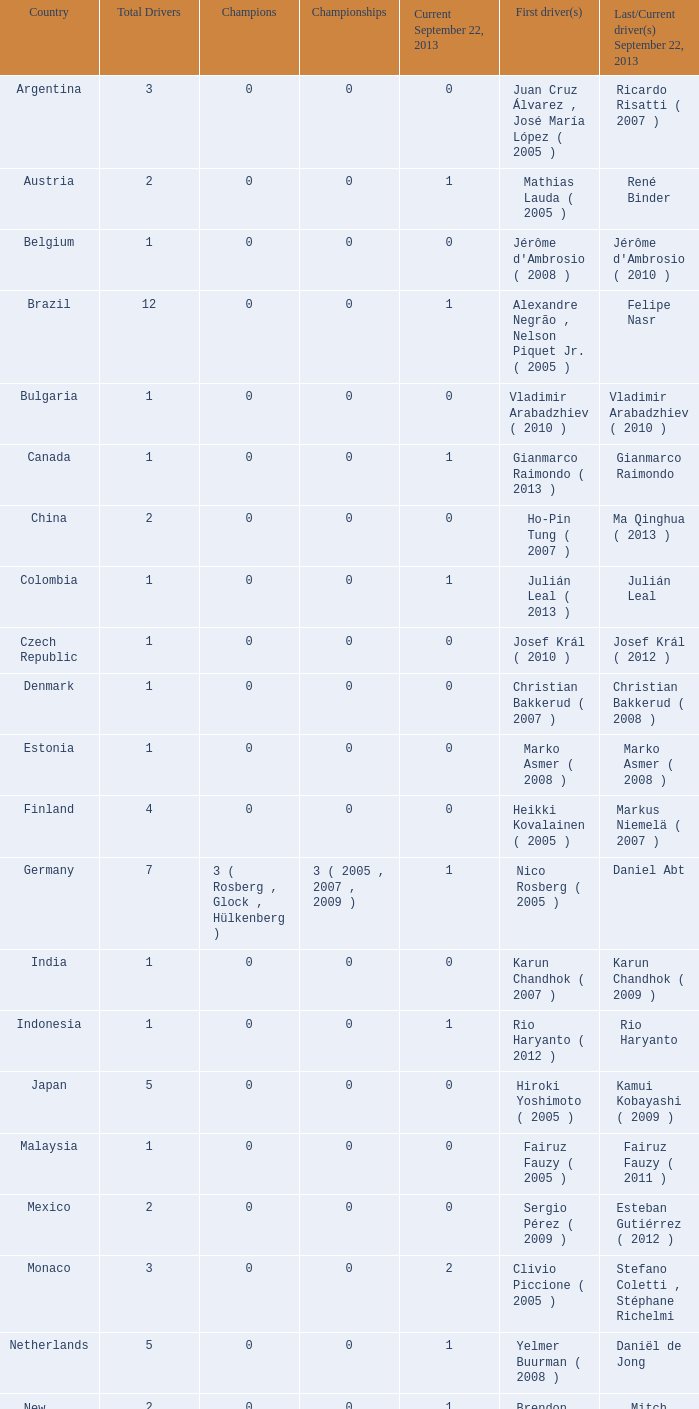When vladimir arabadzhiev (2010) was the concluding driver on september 22, 2013, how many champions were there? 0.0. Would you be able to parse every entry in this table? {'header': ['Country', 'Total Drivers', 'Champions', 'Championships', 'Current September 22, 2013', 'First driver(s)', 'Last/Current driver(s) September 22, 2013'], 'rows': [['Argentina', '3', '0', '0', '0', 'Juan Cruz Álvarez , José María López ( 2005 )', 'Ricardo Risatti ( 2007 )'], ['Austria', '2', '0', '0', '1', 'Mathias Lauda ( 2005 )', 'René Binder'], ['Belgium', '1', '0', '0', '0', "Jérôme d'Ambrosio ( 2008 )", "Jérôme d'Ambrosio ( 2010 )"], ['Brazil', '12', '0', '0', '1', 'Alexandre Negrão , Nelson Piquet Jr. ( 2005 )', 'Felipe Nasr'], ['Bulgaria', '1', '0', '0', '0', 'Vladimir Arabadzhiev ( 2010 )', 'Vladimir Arabadzhiev ( 2010 )'], ['Canada', '1', '0', '0', '1', 'Gianmarco Raimondo ( 2013 )', 'Gianmarco Raimondo'], ['China', '2', '0', '0', '0', 'Ho-Pin Tung ( 2007 )', 'Ma Qinghua ( 2013 )'], ['Colombia', '1', '0', '0', '1', 'Julián Leal ( 2013 )', 'Julián Leal'], ['Czech Republic', '1', '0', '0', '0', 'Josef Král ( 2010 )', 'Josef Král ( 2012 )'], ['Denmark', '1', '0', '0', '0', 'Christian Bakkerud ( 2007 )', 'Christian Bakkerud ( 2008 )'], ['Estonia', '1', '0', '0', '0', 'Marko Asmer ( 2008 )', 'Marko Asmer ( 2008 )'], ['Finland', '4', '0', '0', '0', 'Heikki Kovalainen ( 2005 )', 'Markus Niemelä ( 2007 )'], ['Germany', '7', '3 ( Rosberg , Glock , Hülkenberg )', '3 ( 2005 , 2007 , 2009 )', '1', 'Nico Rosberg ( 2005 )', 'Daniel Abt'], ['India', '1', '0', '0', '0', 'Karun Chandhok ( 2007 )', 'Karun Chandhok ( 2009 )'], ['Indonesia', '1', '0', '0', '1', 'Rio Haryanto ( 2012 )', 'Rio Haryanto'], ['Japan', '5', '0', '0', '0', 'Hiroki Yoshimoto ( 2005 )', 'Kamui Kobayashi ( 2009 )'], ['Malaysia', '1', '0', '0', '0', 'Fairuz Fauzy ( 2005 )', 'Fairuz Fauzy ( 2011 )'], ['Mexico', '2', '0', '0', '0', 'Sergio Pérez ( 2009 )', 'Esteban Gutiérrez ( 2012 )'], ['Monaco', '3', '0', '0', '2', 'Clivio Piccione ( 2005 )', 'Stefano Coletti , Stéphane Richelmi'], ['Netherlands', '5', '0', '0', '1', 'Yelmer Buurman ( 2008 )', 'Daniël de Jong'], ['New Zealand', '2', '0', '0', '1', 'Brendon Hartley ( 2010 )', 'Mitch Evans'], ['Norway', '1', '0', '0', '0', 'Pål Varhaug ( 2011 )', 'Pål Varhaug ( 2013 )'], ['Portugal', '3', '0', '0', '1', 'Filipe Albuquerque ( 2007 )', 'Ricardo Teixeira'], ['Romania', '1', '0', '0', '0', 'Michael Herck ( 2008 )', 'Michael Herck ( 2011 )'], ['Russia', '2', '0', '0', '0', 'Vitaly Petrov ( 2006 )', 'Mikhail Aleshin ( 2011 )'], ['Serbia', '1', '0', '0', '0', 'Miloš Pavlović ( 2008 )', 'Miloš Pavlović ( 2008 )'], ['South Africa', '1', '0', '0', '0', 'Adrian Zaugg ( 2007 )', 'Adrian Zaugg ( 2010 )'], ['Spain', '10', '0', '0', '2', 'Borja García , Sergio Hernández ( 2005 )', 'Sergio Canamasas , Dani Clos'], ['Sweden', '1', '0', '0', '1', 'Marcus Ericsson ( 2010 )', 'Marcus Ericsson'], ['Switzerland', '5', '0', '0', '2', 'Neel Jani ( 2005 )', 'Fabio Leimer , Simon Trummer'], ['Turkey', '2', '0', '0', '0', 'Can Artam ( 2005 )', 'Jason Tahincioglu ( 2007 )'], ['United Arab Emirates', '1', '0', '0', '0', 'Andreas Zuber ( 2006 )', 'Andreas Zuber ( 2009 )'], ['United States', '4', '0', '0', '2', 'Scott Speed ( 2005 )', 'Jake Rosenzweig , Alexander Rossi']]} 